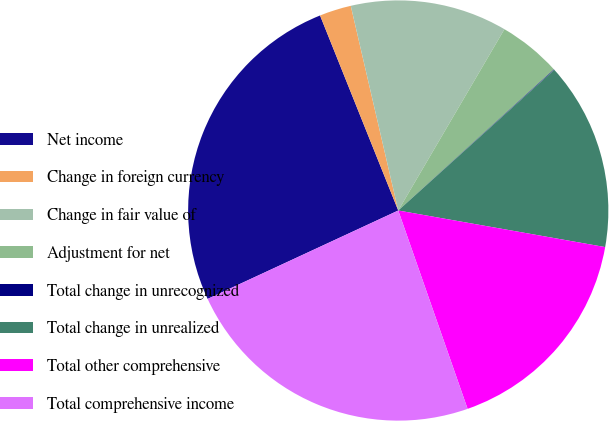Convert chart. <chart><loc_0><loc_0><loc_500><loc_500><pie_chart><fcel>Net income<fcel>Change in foreign currency<fcel>Change in fair value of<fcel>Adjustment for net<fcel>Total change in unrecognized<fcel>Total change in unrealized<fcel>Total other comprehensive<fcel>Total comprehensive income<nl><fcel>25.84%<fcel>2.44%<fcel>12.06%<fcel>4.85%<fcel>0.04%<fcel>14.46%<fcel>16.86%<fcel>23.44%<nl></chart> 